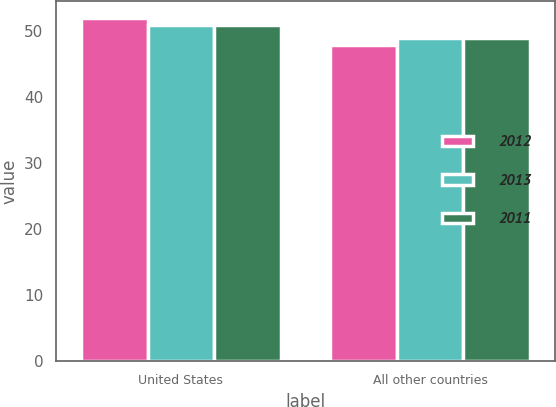Convert chart to OTSL. <chart><loc_0><loc_0><loc_500><loc_500><stacked_bar_chart><ecel><fcel>United States<fcel>All other countries<nl><fcel>2012<fcel>52<fcel>48<nl><fcel>2013<fcel>51<fcel>49<nl><fcel>2011<fcel>51<fcel>49<nl></chart> 